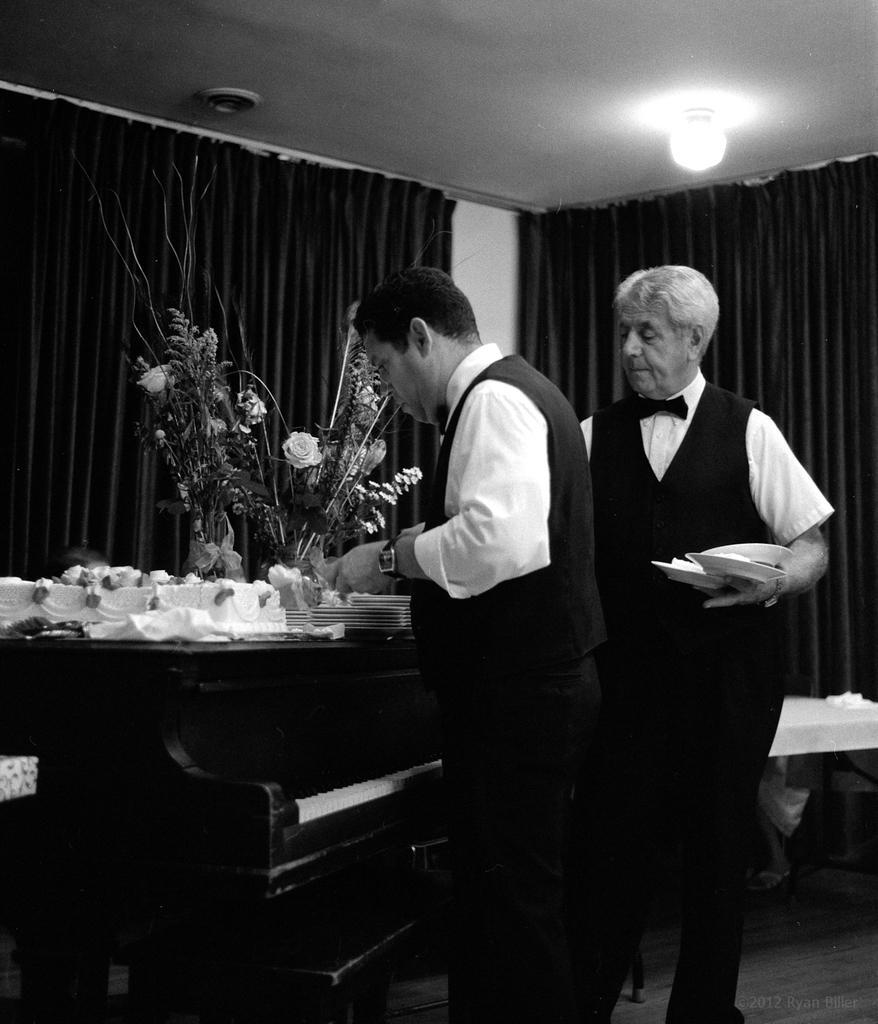Could you give a brief overview of what you see in this image? This is a black and white picture. Here we can see two persons are standing on the floor. This is table. On the table there are plates and a flower vase. On the background there is a curtain and this is light. 